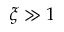Convert formula to latex. <formula><loc_0><loc_0><loc_500><loc_500>\xi \gg 1</formula> 